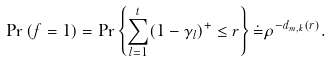Convert formula to latex. <formula><loc_0><loc_0><loc_500><loc_500>\Pr \left ( f = 1 \right ) = \Pr \left \{ \sum _ { l = 1 } ^ { t } ( 1 - \gamma _ { l } ) ^ { + } \leq r \right \} \dot { = } \rho ^ { - d _ { m , k } ( r ) } .</formula> 